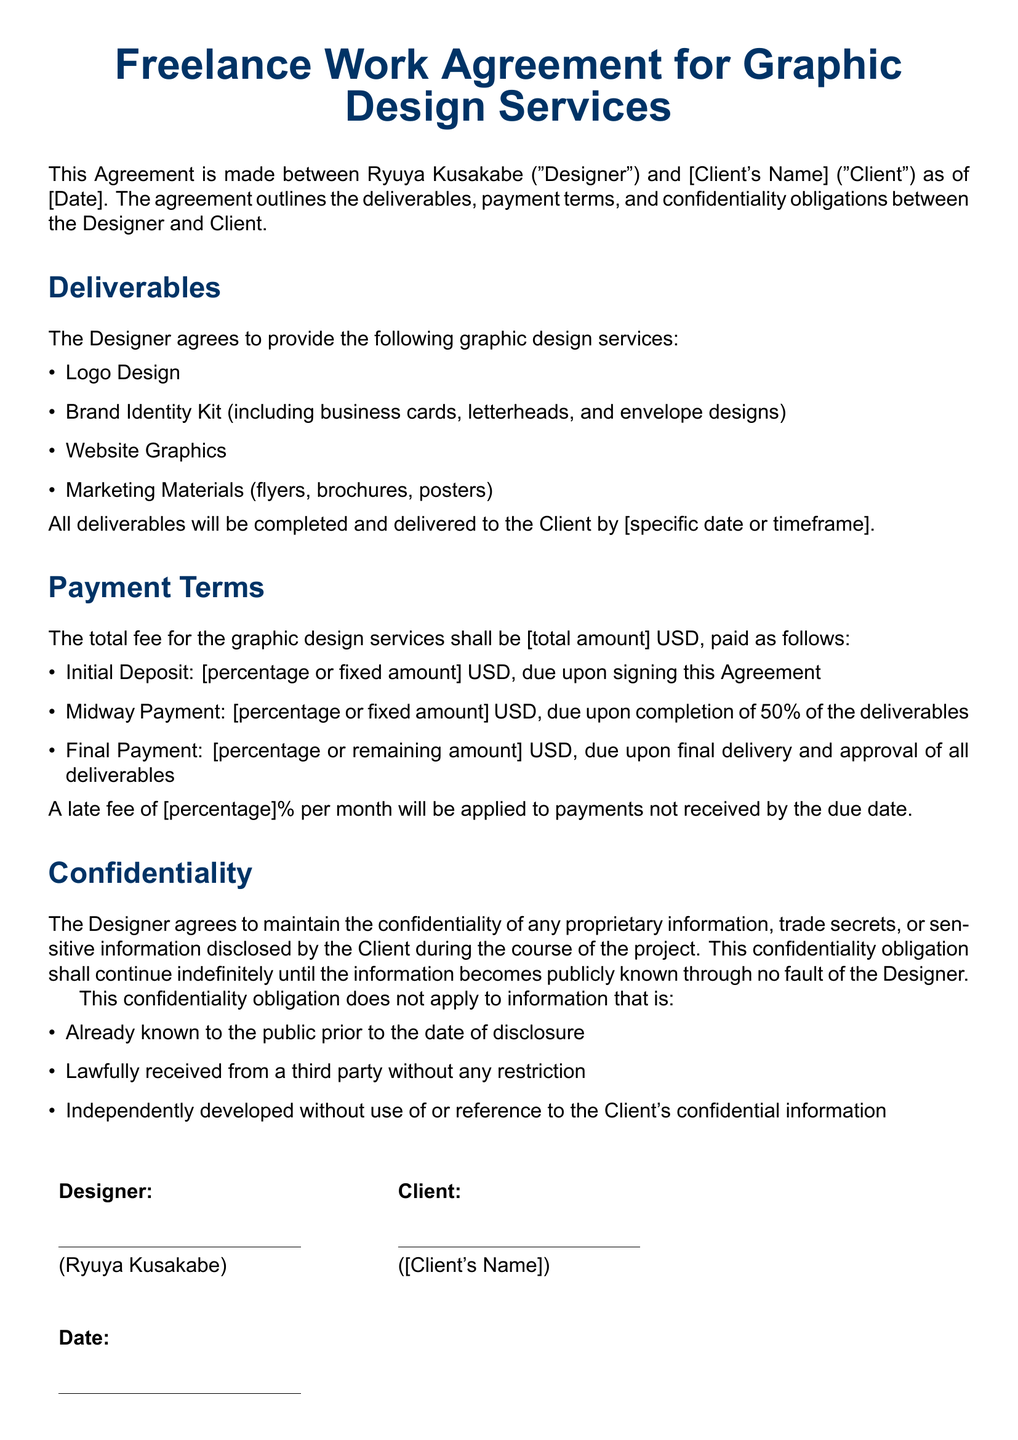What is the total fee for the graphic design services? The total fee is mentioned in the payment terms section of the document, which states it as [total amount] USD.
Answer: [total amount] USD What are the names of the parties involved in the agreement? The agreement involves Ryuya Kusakabe as the Designer and [Client's Name] as the Client.
Answer: Ryuya Kusakabe and [Client's Name] What is the initial deposit due upon signing the agreement? The initial deposit amount is specified in the payment terms section as [percentage or fixed amount] USD.
Answer: [percentage or fixed amount] USD What service is listed first in the deliverables? The deliverables section lists the services to be provided, with Logo Design as the first item.
Answer: Logo Design How long does the confidentiality obligation last? The document states that the confidentiality obligation shall continue indefinitely until the information becomes publicly known through no fault of the Designer.
Answer: Indefinitely When is the final payment due? The final payment is due upon final delivery and approval of all deliverables, as stated in the payment terms section.
Answer: Upon final delivery and approval What is the percentage for the late fee if payments are not received on time? The late fee percentage is specified in the payment terms section as [percentage]% per month.
Answer: [percentage]% What type of information is the Designer obligated to keep confidential? The Designer agrees to maintain confidentiality over proprietary information, trade secrets, or sensitive information disclosed by the Client.
Answer: Proprietary information, trade secrets, or sensitive information What is included in the Brand Identity Kit deliverable? The Brand Identity Kit includes business cards, letterheads, and envelope designs as mentioned in the deliverables section.
Answer: Business cards, letterheads, and envelope designs 